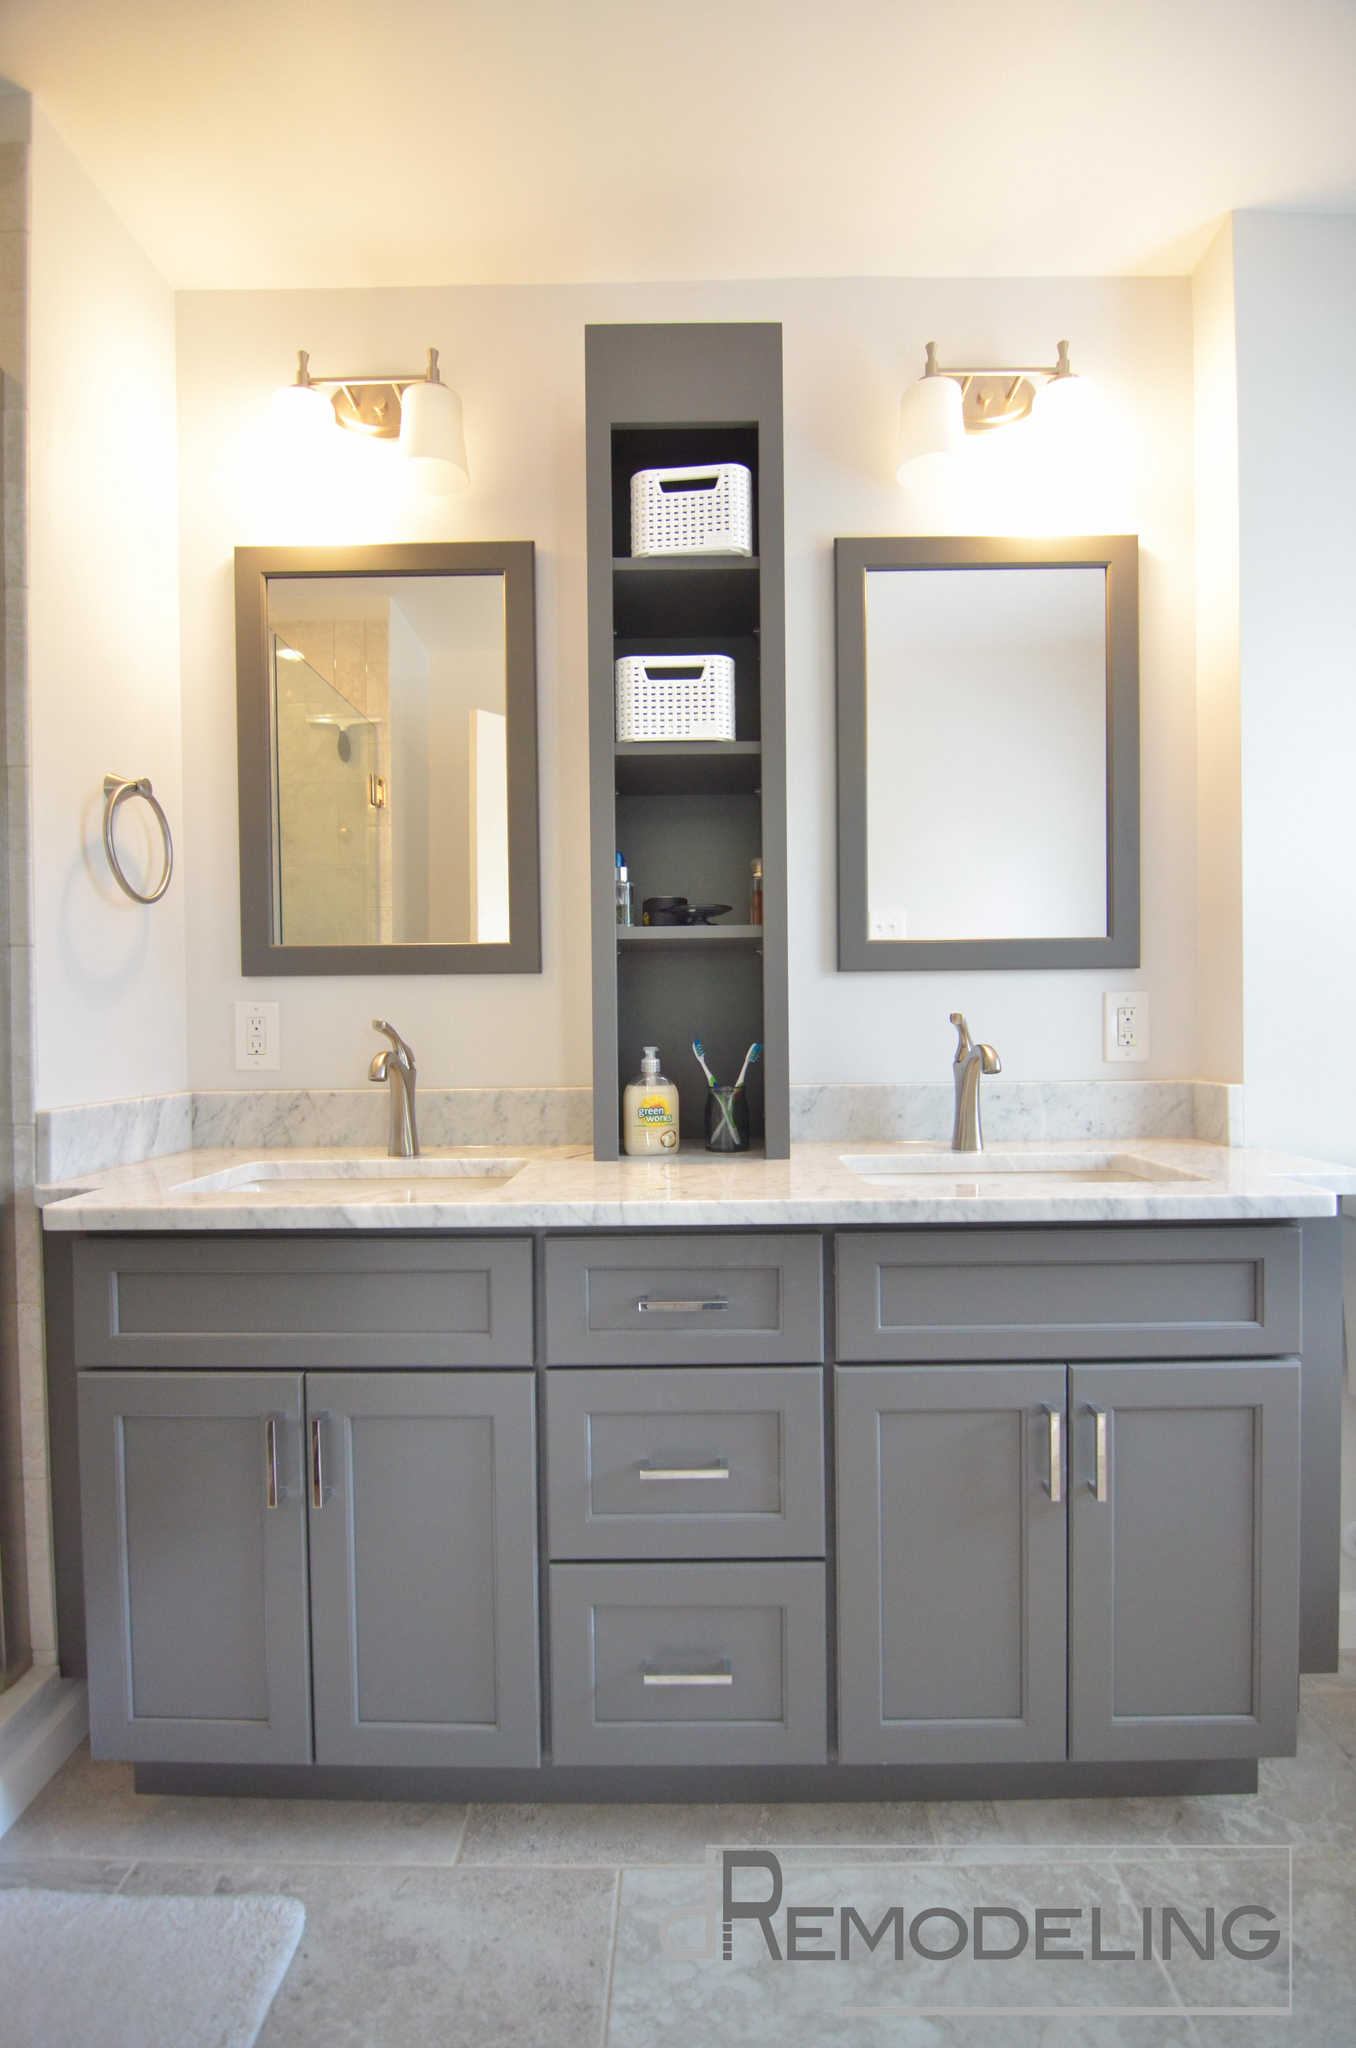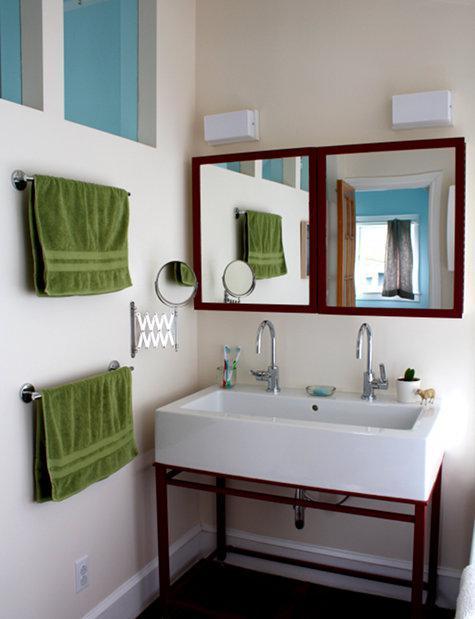The first image is the image on the left, the second image is the image on the right. Considering the images on both sides, is "A bathroom features two black-framed rectangular mirrors over a double-sink vaniety with a black cabinet." valid? Answer yes or no. No. The first image is the image on the left, the second image is the image on the right. Assess this claim about the two images: "One picture has mirrors with black borders". Correct or not? Answer yes or no. No. 